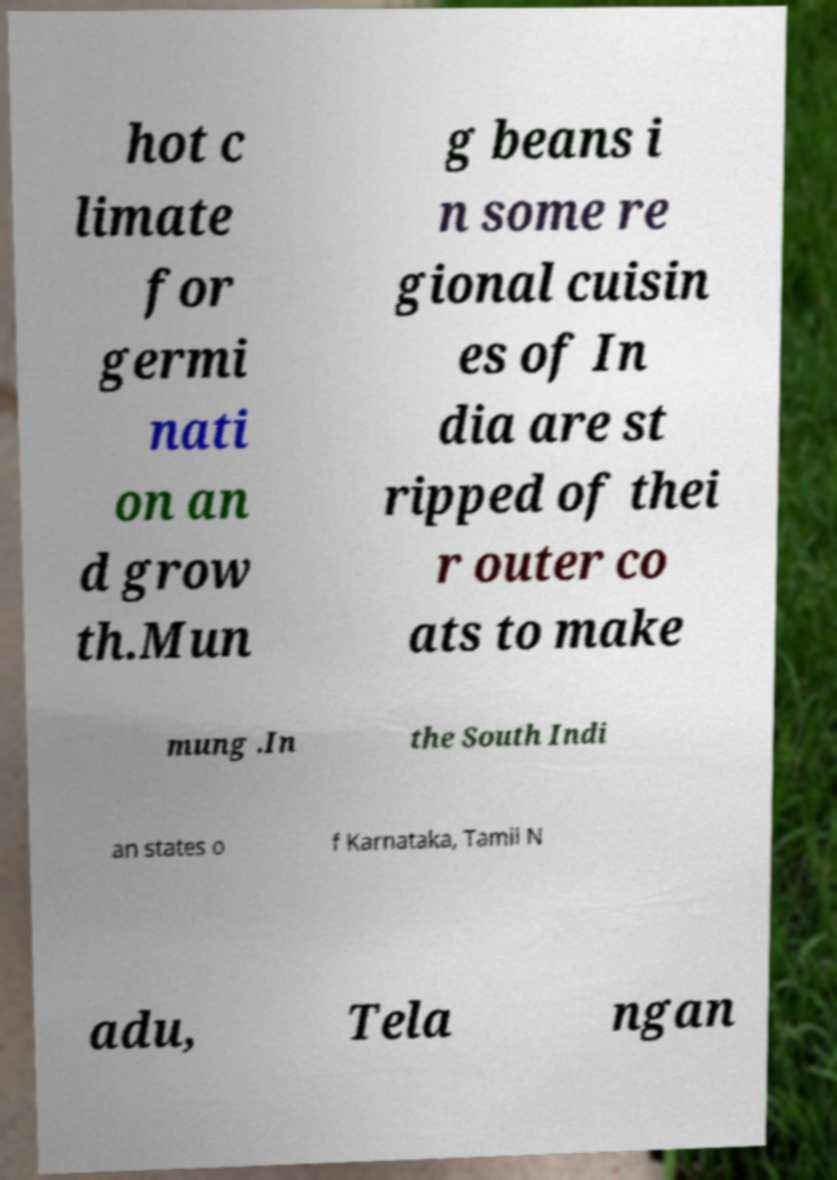Could you assist in decoding the text presented in this image and type it out clearly? hot c limate for germi nati on an d grow th.Mun g beans i n some re gional cuisin es of In dia are st ripped of thei r outer co ats to make mung .In the South Indi an states o f Karnataka, Tamil N adu, Tela ngan 